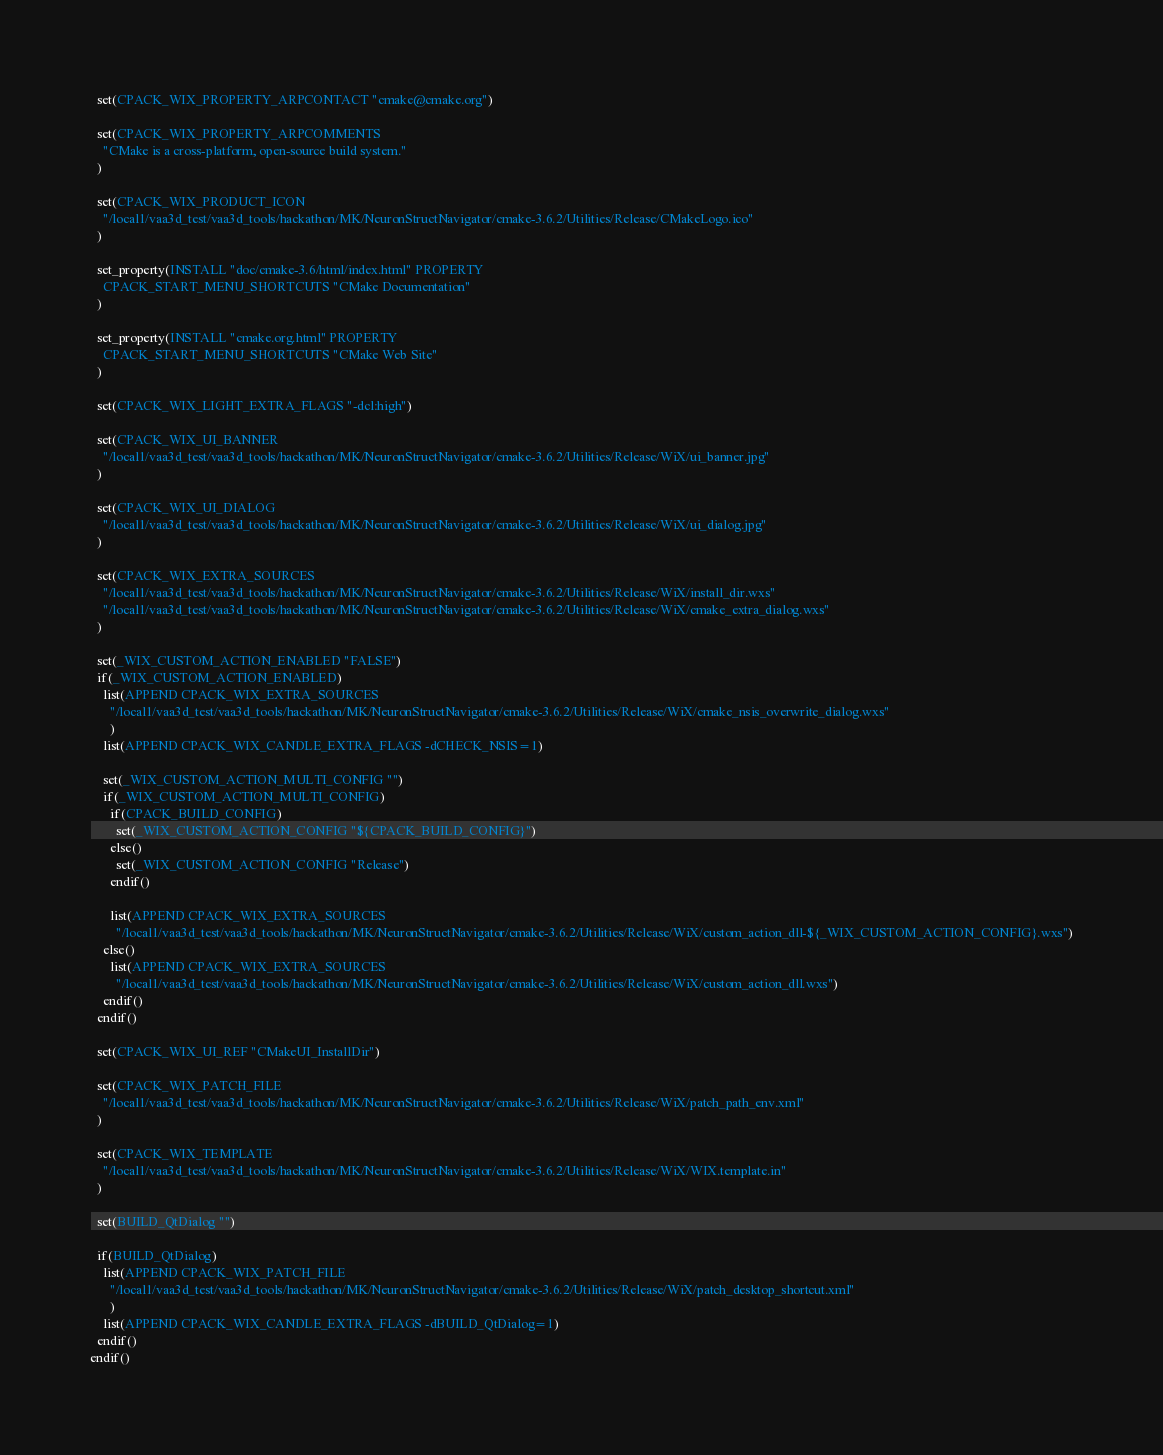<code> <loc_0><loc_0><loc_500><loc_500><_CMake_>  set(CPACK_WIX_PROPERTY_ARPCONTACT "cmake@cmake.org")

  set(CPACK_WIX_PROPERTY_ARPCOMMENTS
    "CMake is a cross-platform, open-source build system."
  )

  set(CPACK_WIX_PRODUCT_ICON
    "/local1/vaa3d_test/vaa3d_tools/hackathon/MK/NeuronStructNavigator/cmake-3.6.2/Utilities/Release/CMakeLogo.ico"
  )

  set_property(INSTALL "doc/cmake-3.6/html/index.html" PROPERTY
    CPACK_START_MENU_SHORTCUTS "CMake Documentation"
  )

  set_property(INSTALL "cmake.org.html" PROPERTY
    CPACK_START_MENU_SHORTCUTS "CMake Web Site"
  )

  set(CPACK_WIX_LIGHT_EXTRA_FLAGS "-dcl:high")

  set(CPACK_WIX_UI_BANNER
    "/local1/vaa3d_test/vaa3d_tools/hackathon/MK/NeuronStructNavigator/cmake-3.6.2/Utilities/Release/WiX/ui_banner.jpg"
  )

  set(CPACK_WIX_UI_DIALOG
    "/local1/vaa3d_test/vaa3d_tools/hackathon/MK/NeuronStructNavigator/cmake-3.6.2/Utilities/Release/WiX/ui_dialog.jpg"
  )

  set(CPACK_WIX_EXTRA_SOURCES
    "/local1/vaa3d_test/vaa3d_tools/hackathon/MK/NeuronStructNavigator/cmake-3.6.2/Utilities/Release/WiX/install_dir.wxs"
    "/local1/vaa3d_test/vaa3d_tools/hackathon/MK/NeuronStructNavigator/cmake-3.6.2/Utilities/Release/WiX/cmake_extra_dialog.wxs"
  )

  set(_WIX_CUSTOM_ACTION_ENABLED "FALSE")
  if(_WIX_CUSTOM_ACTION_ENABLED)
    list(APPEND CPACK_WIX_EXTRA_SOURCES
      "/local1/vaa3d_test/vaa3d_tools/hackathon/MK/NeuronStructNavigator/cmake-3.6.2/Utilities/Release/WiX/cmake_nsis_overwrite_dialog.wxs"
      )
    list(APPEND CPACK_WIX_CANDLE_EXTRA_FLAGS -dCHECK_NSIS=1)

    set(_WIX_CUSTOM_ACTION_MULTI_CONFIG "")
    if(_WIX_CUSTOM_ACTION_MULTI_CONFIG)
      if(CPACK_BUILD_CONFIG)
        set(_WIX_CUSTOM_ACTION_CONFIG "${CPACK_BUILD_CONFIG}")
      else()
        set(_WIX_CUSTOM_ACTION_CONFIG "Release")
      endif()

      list(APPEND CPACK_WIX_EXTRA_SOURCES
        "/local1/vaa3d_test/vaa3d_tools/hackathon/MK/NeuronStructNavigator/cmake-3.6.2/Utilities/Release/WiX/custom_action_dll-${_WIX_CUSTOM_ACTION_CONFIG}.wxs")
    else()
      list(APPEND CPACK_WIX_EXTRA_SOURCES
        "/local1/vaa3d_test/vaa3d_tools/hackathon/MK/NeuronStructNavigator/cmake-3.6.2/Utilities/Release/WiX/custom_action_dll.wxs")
    endif()
  endif()

  set(CPACK_WIX_UI_REF "CMakeUI_InstallDir")

  set(CPACK_WIX_PATCH_FILE
    "/local1/vaa3d_test/vaa3d_tools/hackathon/MK/NeuronStructNavigator/cmake-3.6.2/Utilities/Release/WiX/patch_path_env.xml"
  )

  set(CPACK_WIX_TEMPLATE
    "/local1/vaa3d_test/vaa3d_tools/hackathon/MK/NeuronStructNavigator/cmake-3.6.2/Utilities/Release/WiX/WIX.template.in"
  )

  set(BUILD_QtDialog "")

  if(BUILD_QtDialog)
    list(APPEND CPACK_WIX_PATCH_FILE
      "/local1/vaa3d_test/vaa3d_tools/hackathon/MK/NeuronStructNavigator/cmake-3.6.2/Utilities/Release/WiX/patch_desktop_shortcut.xml"
      )
    list(APPEND CPACK_WIX_CANDLE_EXTRA_FLAGS -dBUILD_QtDialog=1)
  endif()
endif()
</code> 